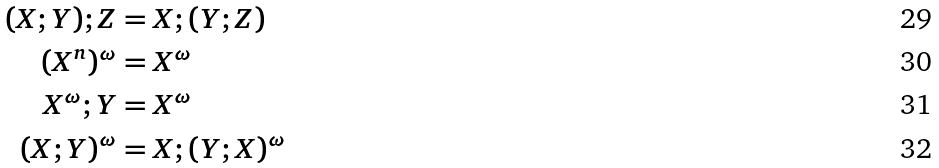Convert formula to latex. <formula><loc_0><loc_0><loc_500><loc_500>( X ; Y ) ; Z & = X ; ( Y ; Z ) \\ ( X ^ { n } ) ^ { \omega } & = X ^ { \omega } \\ X ^ { \omega } ; Y & = X ^ { \omega } \\ ( X ; Y ) ^ { \omega } & = X ; ( Y ; X ) ^ { \omega }</formula> 